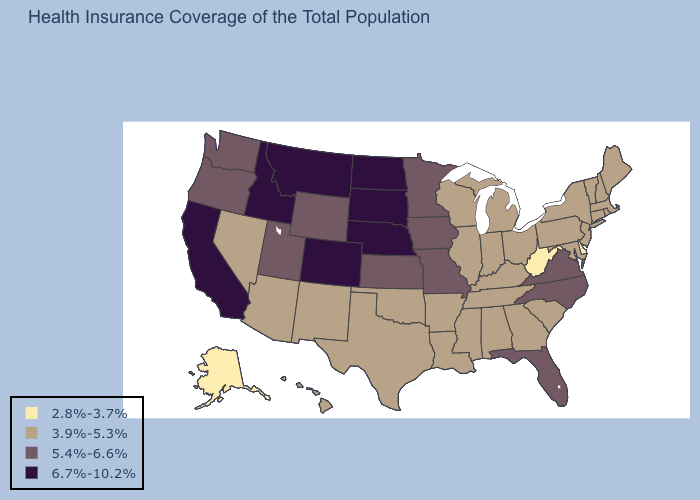Does Nebraska have a higher value than Arizona?
Answer briefly. Yes. What is the value of Wyoming?
Be succinct. 5.4%-6.6%. Which states have the lowest value in the USA?
Short answer required. Alaska, Delaware, West Virginia. Among the states that border South Carolina , does North Carolina have the highest value?
Keep it brief. Yes. Does New Jersey have a higher value than Alaska?
Give a very brief answer. Yes. What is the value of Maryland?
Concise answer only. 3.9%-5.3%. Which states have the highest value in the USA?
Write a very short answer. California, Colorado, Idaho, Montana, Nebraska, North Dakota, South Dakota. Does Alaska have the lowest value in the USA?
Write a very short answer. Yes. Which states have the highest value in the USA?
Quick response, please. California, Colorado, Idaho, Montana, Nebraska, North Dakota, South Dakota. Among the states that border Idaho , does Nevada have the lowest value?
Short answer required. Yes. Which states have the lowest value in the South?
Be succinct. Delaware, West Virginia. What is the value of Oklahoma?
Answer briefly. 3.9%-5.3%. Among the states that border North Carolina , does Virginia have the highest value?
Answer briefly. Yes. 